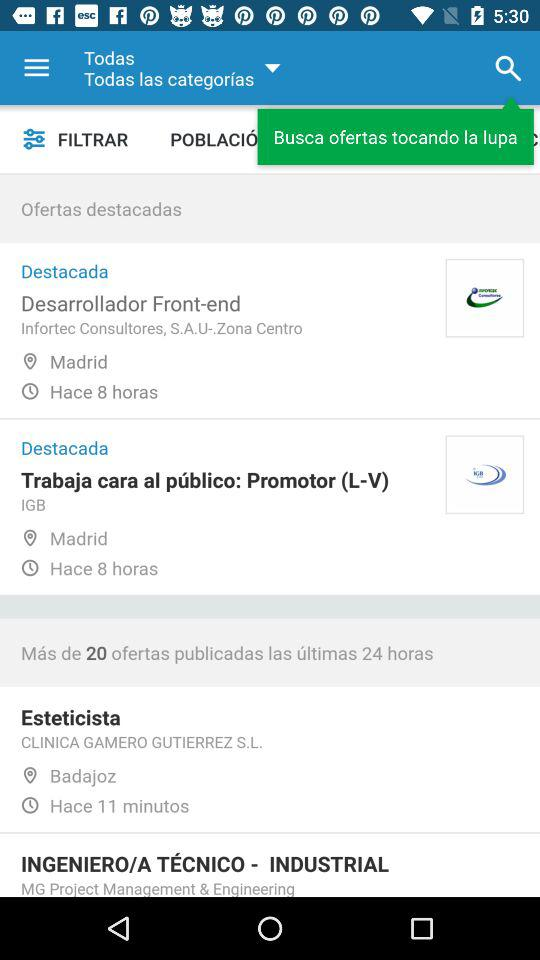How many of the highlighted jobs are in Madrid?
Answer the question using a single word or phrase. 2 